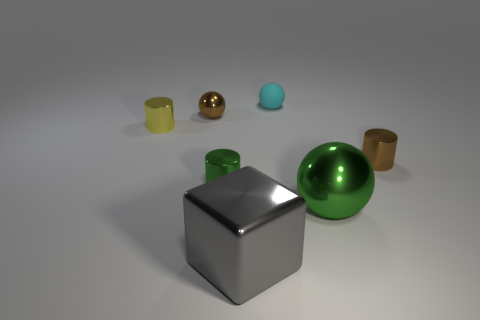Add 3 brown metallic cylinders. How many objects exist? 10 Subtract all blocks. How many objects are left? 6 Add 1 large things. How many large things are left? 3 Add 7 tiny rubber spheres. How many tiny rubber spheres exist? 8 Subtract 0 gray cylinders. How many objects are left? 7 Subtract all spheres. Subtract all small gray spheres. How many objects are left? 4 